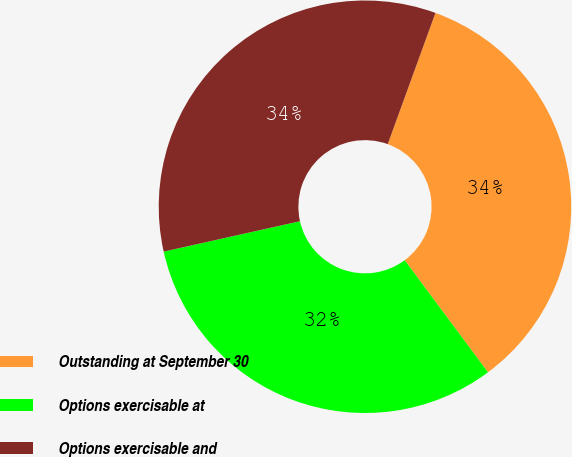Convert chart. <chart><loc_0><loc_0><loc_500><loc_500><pie_chart><fcel>Outstanding at September 30<fcel>Options exercisable at<fcel>Options exercisable and<nl><fcel>34.28%<fcel>31.68%<fcel>34.04%<nl></chart> 